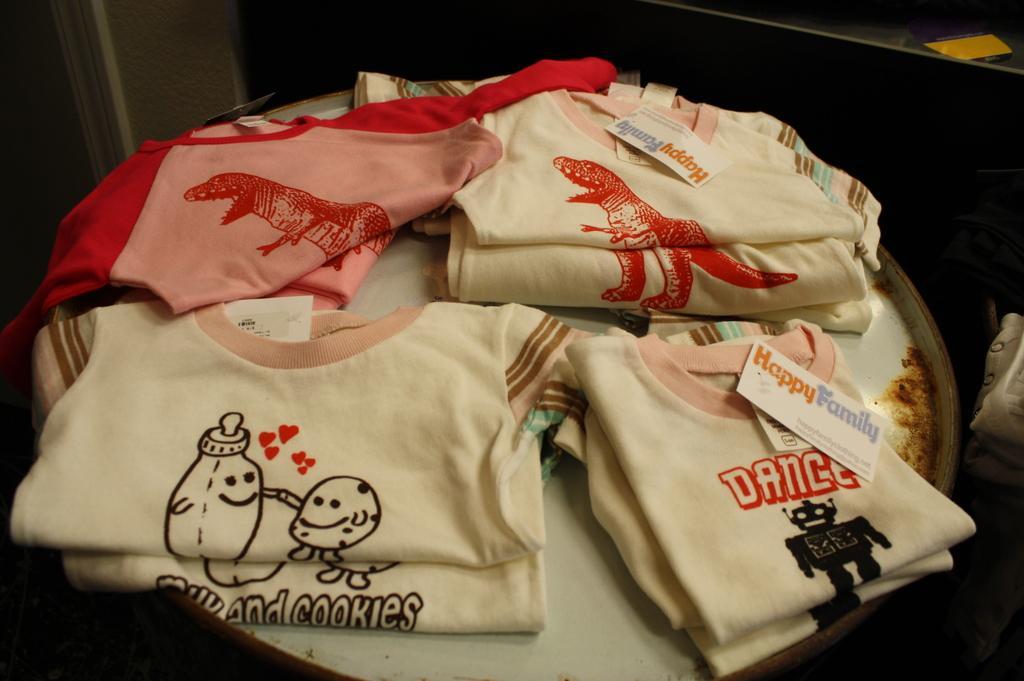Describe this image in one or two sentences. In the image we can see folded clothes and the background is slightly dark. 